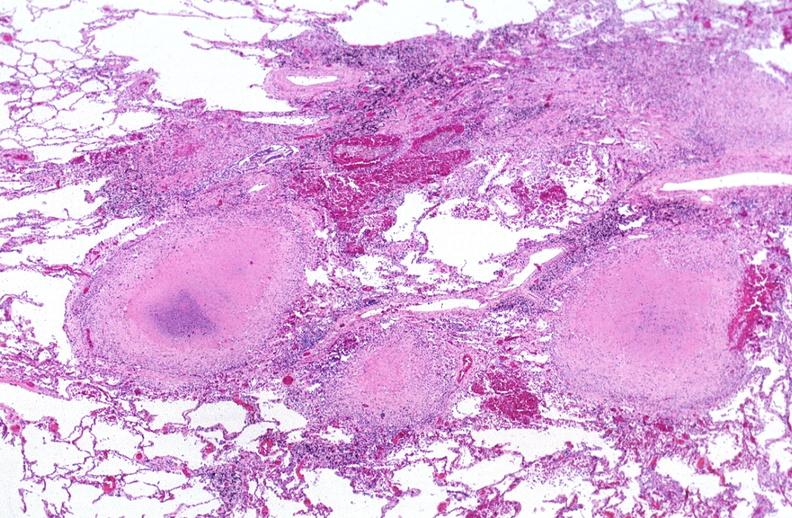what does this image show?
Answer the question using a single word or phrase. Lung 